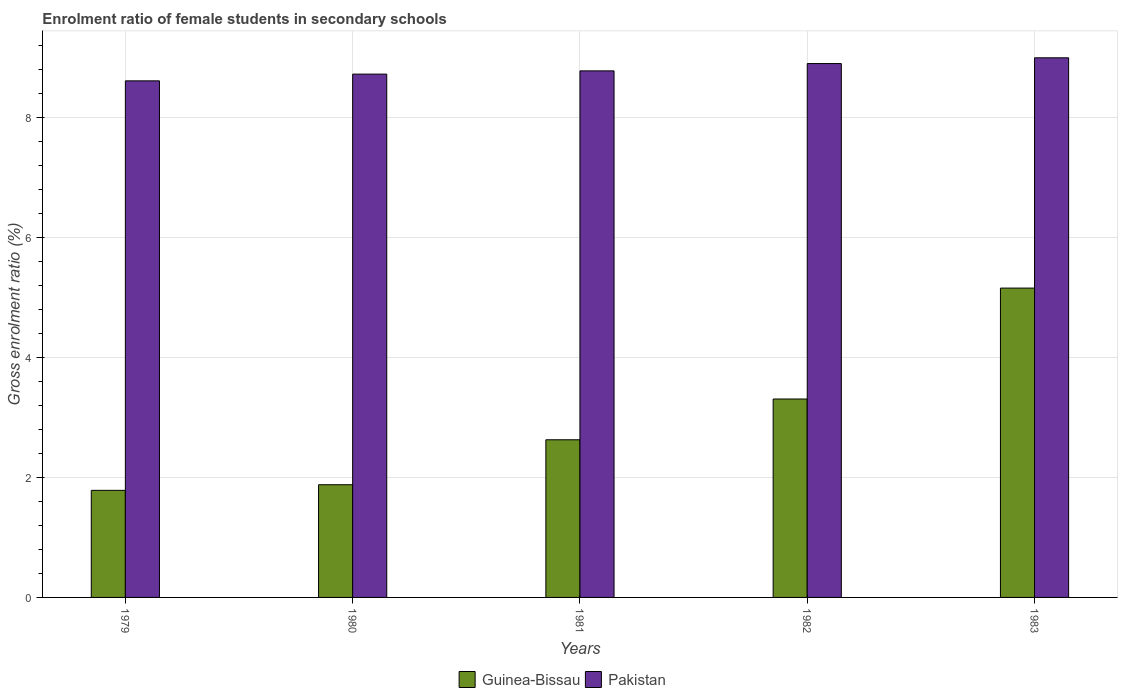How many groups of bars are there?
Offer a terse response. 5. Are the number of bars per tick equal to the number of legend labels?
Your answer should be very brief. Yes. How many bars are there on the 5th tick from the right?
Give a very brief answer. 2. What is the label of the 5th group of bars from the left?
Provide a short and direct response. 1983. What is the enrolment ratio of female students in secondary schools in Guinea-Bissau in 1980?
Provide a short and direct response. 1.88. Across all years, what is the maximum enrolment ratio of female students in secondary schools in Guinea-Bissau?
Your answer should be very brief. 5.16. Across all years, what is the minimum enrolment ratio of female students in secondary schools in Pakistan?
Your answer should be very brief. 8.61. In which year was the enrolment ratio of female students in secondary schools in Pakistan minimum?
Offer a terse response. 1979. What is the total enrolment ratio of female students in secondary schools in Guinea-Bissau in the graph?
Give a very brief answer. 14.75. What is the difference between the enrolment ratio of female students in secondary schools in Pakistan in 1980 and that in 1982?
Offer a very short reply. -0.18. What is the difference between the enrolment ratio of female students in secondary schools in Pakistan in 1983 and the enrolment ratio of female students in secondary schools in Guinea-Bissau in 1979?
Give a very brief answer. 7.21. What is the average enrolment ratio of female students in secondary schools in Guinea-Bissau per year?
Provide a short and direct response. 2.95. In the year 1981, what is the difference between the enrolment ratio of female students in secondary schools in Guinea-Bissau and enrolment ratio of female students in secondary schools in Pakistan?
Your response must be concise. -6.15. In how many years, is the enrolment ratio of female students in secondary schools in Guinea-Bissau greater than 4.4 %?
Keep it short and to the point. 1. What is the ratio of the enrolment ratio of female students in secondary schools in Pakistan in 1980 to that in 1983?
Offer a very short reply. 0.97. Is the enrolment ratio of female students in secondary schools in Pakistan in 1981 less than that in 1983?
Provide a succinct answer. Yes. Is the difference between the enrolment ratio of female students in secondary schools in Guinea-Bissau in 1980 and 1983 greater than the difference between the enrolment ratio of female students in secondary schools in Pakistan in 1980 and 1983?
Keep it short and to the point. No. What is the difference between the highest and the second highest enrolment ratio of female students in secondary schools in Guinea-Bissau?
Keep it short and to the point. 1.85. What is the difference between the highest and the lowest enrolment ratio of female students in secondary schools in Guinea-Bissau?
Ensure brevity in your answer.  3.37. In how many years, is the enrolment ratio of female students in secondary schools in Pakistan greater than the average enrolment ratio of female students in secondary schools in Pakistan taken over all years?
Provide a short and direct response. 2. Is the sum of the enrolment ratio of female students in secondary schools in Guinea-Bissau in 1980 and 1982 greater than the maximum enrolment ratio of female students in secondary schools in Pakistan across all years?
Provide a succinct answer. No. What does the 2nd bar from the left in 1980 represents?
Provide a succinct answer. Pakistan. What does the 1st bar from the right in 1980 represents?
Your answer should be very brief. Pakistan. How many bars are there?
Your answer should be compact. 10. Are all the bars in the graph horizontal?
Make the answer very short. No. How many years are there in the graph?
Provide a succinct answer. 5. Are the values on the major ticks of Y-axis written in scientific E-notation?
Keep it short and to the point. No. Does the graph contain grids?
Your answer should be compact. Yes. How many legend labels are there?
Offer a very short reply. 2. What is the title of the graph?
Keep it short and to the point. Enrolment ratio of female students in secondary schools. Does "Kyrgyz Republic" appear as one of the legend labels in the graph?
Ensure brevity in your answer.  No. What is the label or title of the Y-axis?
Your answer should be very brief. Gross enrolment ratio (%). What is the Gross enrolment ratio (%) in Guinea-Bissau in 1979?
Provide a succinct answer. 1.78. What is the Gross enrolment ratio (%) in Pakistan in 1979?
Your answer should be compact. 8.61. What is the Gross enrolment ratio (%) of Guinea-Bissau in 1980?
Your answer should be compact. 1.88. What is the Gross enrolment ratio (%) of Pakistan in 1980?
Keep it short and to the point. 8.72. What is the Gross enrolment ratio (%) in Guinea-Bissau in 1981?
Keep it short and to the point. 2.63. What is the Gross enrolment ratio (%) of Pakistan in 1981?
Provide a short and direct response. 8.78. What is the Gross enrolment ratio (%) in Guinea-Bissau in 1982?
Offer a very short reply. 3.31. What is the Gross enrolment ratio (%) in Pakistan in 1982?
Give a very brief answer. 8.9. What is the Gross enrolment ratio (%) of Guinea-Bissau in 1983?
Provide a succinct answer. 5.16. What is the Gross enrolment ratio (%) of Pakistan in 1983?
Provide a succinct answer. 8.99. Across all years, what is the maximum Gross enrolment ratio (%) of Guinea-Bissau?
Your answer should be very brief. 5.16. Across all years, what is the maximum Gross enrolment ratio (%) of Pakistan?
Give a very brief answer. 8.99. Across all years, what is the minimum Gross enrolment ratio (%) in Guinea-Bissau?
Provide a short and direct response. 1.78. Across all years, what is the minimum Gross enrolment ratio (%) of Pakistan?
Ensure brevity in your answer.  8.61. What is the total Gross enrolment ratio (%) of Guinea-Bissau in the graph?
Provide a succinct answer. 14.75. What is the total Gross enrolment ratio (%) of Pakistan in the graph?
Your answer should be very brief. 44. What is the difference between the Gross enrolment ratio (%) of Guinea-Bissau in 1979 and that in 1980?
Provide a succinct answer. -0.09. What is the difference between the Gross enrolment ratio (%) of Pakistan in 1979 and that in 1980?
Ensure brevity in your answer.  -0.11. What is the difference between the Gross enrolment ratio (%) of Guinea-Bissau in 1979 and that in 1981?
Offer a very short reply. -0.84. What is the difference between the Gross enrolment ratio (%) of Pakistan in 1979 and that in 1981?
Offer a terse response. -0.17. What is the difference between the Gross enrolment ratio (%) of Guinea-Bissau in 1979 and that in 1982?
Your response must be concise. -1.52. What is the difference between the Gross enrolment ratio (%) in Pakistan in 1979 and that in 1982?
Your answer should be very brief. -0.29. What is the difference between the Gross enrolment ratio (%) in Guinea-Bissau in 1979 and that in 1983?
Give a very brief answer. -3.37. What is the difference between the Gross enrolment ratio (%) in Pakistan in 1979 and that in 1983?
Offer a terse response. -0.38. What is the difference between the Gross enrolment ratio (%) of Guinea-Bissau in 1980 and that in 1981?
Your answer should be very brief. -0.75. What is the difference between the Gross enrolment ratio (%) in Pakistan in 1980 and that in 1981?
Make the answer very short. -0.05. What is the difference between the Gross enrolment ratio (%) of Guinea-Bissau in 1980 and that in 1982?
Make the answer very short. -1.43. What is the difference between the Gross enrolment ratio (%) of Pakistan in 1980 and that in 1982?
Provide a succinct answer. -0.18. What is the difference between the Gross enrolment ratio (%) in Guinea-Bissau in 1980 and that in 1983?
Keep it short and to the point. -3.28. What is the difference between the Gross enrolment ratio (%) of Pakistan in 1980 and that in 1983?
Provide a short and direct response. -0.27. What is the difference between the Gross enrolment ratio (%) of Guinea-Bissau in 1981 and that in 1982?
Provide a short and direct response. -0.68. What is the difference between the Gross enrolment ratio (%) of Pakistan in 1981 and that in 1982?
Provide a short and direct response. -0.12. What is the difference between the Gross enrolment ratio (%) in Guinea-Bissau in 1981 and that in 1983?
Give a very brief answer. -2.53. What is the difference between the Gross enrolment ratio (%) in Pakistan in 1981 and that in 1983?
Make the answer very short. -0.22. What is the difference between the Gross enrolment ratio (%) of Guinea-Bissau in 1982 and that in 1983?
Give a very brief answer. -1.85. What is the difference between the Gross enrolment ratio (%) in Pakistan in 1982 and that in 1983?
Make the answer very short. -0.1. What is the difference between the Gross enrolment ratio (%) in Guinea-Bissau in 1979 and the Gross enrolment ratio (%) in Pakistan in 1980?
Your answer should be compact. -6.94. What is the difference between the Gross enrolment ratio (%) of Guinea-Bissau in 1979 and the Gross enrolment ratio (%) of Pakistan in 1981?
Provide a succinct answer. -6.99. What is the difference between the Gross enrolment ratio (%) of Guinea-Bissau in 1979 and the Gross enrolment ratio (%) of Pakistan in 1982?
Provide a succinct answer. -7.11. What is the difference between the Gross enrolment ratio (%) in Guinea-Bissau in 1979 and the Gross enrolment ratio (%) in Pakistan in 1983?
Your response must be concise. -7.21. What is the difference between the Gross enrolment ratio (%) of Guinea-Bissau in 1980 and the Gross enrolment ratio (%) of Pakistan in 1981?
Keep it short and to the point. -6.9. What is the difference between the Gross enrolment ratio (%) of Guinea-Bissau in 1980 and the Gross enrolment ratio (%) of Pakistan in 1982?
Ensure brevity in your answer.  -7.02. What is the difference between the Gross enrolment ratio (%) of Guinea-Bissau in 1980 and the Gross enrolment ratio (%) of Pakistan in 1983?
Your answer should be very brief. -7.12. What is the difference between the Gross enrolment ratio (%) in Guinea-Bissau in 1981 and the Gross enrolment ratio (%) in Pakistan in 1982?
Offer a terse response. -6.27. What is the difference between the Gross enrolment ratio (%) of Guinea-Bissau in 1981 and the Gross enrolment ratio (%) of Pakistan in 1983?
Your answer should be compact. -6.37. What is the difference between the Gross enrolment ratio (%) of Guinea-Bissau in 1982 and the Gross enrolment ratio (%) of Pakistan in 1983?
Provide a short and direct response. -5.69. What is the average Gross enrolment ratio (%) of Guinea-Bissau per year?
Provide a short and direct response. 2.95. What is the average Gross enrolment ratio (%) in Pakistan per year?
Provide a short and direct response. 8.8. In the year 1979, what is the difference between the Gross enrolment ratio (%) of Guinea-Bissau and Gross enrolment ratio (%) of Pakistan?
Provide a succinct answer. -6.82. In the year 1980, what is the difference between the Gross enrolment ratio (%) in Guinea-Bissau and Gross enrolment ratio (%) in Pakistan?
Your answer should be compact. -6.84. In the year 1981, what is the difference between the Gross enrolment ratio (%) in Guinea-Bissau and Gross enrolment ratio (%) in Pakistan?
Your answer should be compact. -6.15. In the year 1982, what is the difference between the Gross enrolment ratio (%) of Guinea-Bissau and Gross enrolment ratio (%) of Pakistan?
Make the answer very short. -5.59. In the year 1983, what is the difference between the Gross enrolment ratio (%) in Guinea-Bissau and Gross enrolment ratio (%) in Pakistan?
Your response must be concise. -3.84. What is the ratio of the Gross enrolment ratio (%) in Guinea-Bissau in 1979 to that in 1980?
Ensure brevity in your answer.  0.95. What is the ratio of the Gross enrolment ratio (%) of Pakistan in 1979 to that in 1980?
Your response must be concise. 0.99. What is the ratio of the Gross enrolment ratio (%) of Guinea-Bissau in 1979 to that in 1981?
Offer a terse response. 0.68. What is the ratio of the Gross enrolment ratio (%) in Pakistan in 1979 to that in 1981?
Keep it short and to the point. 0.98. What is the ratio of the Gross enrolment ratio (%) in Guinea-Bissau in 1979 to that in 1982?
Your answer should be compact. 0.54. What is the ratio of the Gross enrolment ratio (%) in Pakistan in 1979 to that in 1982?
Make the answer very short. 0.97. What is the ratio of the Gross enrolment ratio (%) in Guinea-Bissau in 1979 to that in 1983?
Provide a short and direct response. 0.35. What is the ratio of the Gross enrolment ratio (%) of Pakistan in 1979 to that in 1983?
Offer a terse response. 0.96. What is the ratio of the Gross enrolment ratio (%) of Guinea-Bissau in 1980 to that in 1981?
Your answer should be compact. 0.71. What is the ratio of the Gross enrolment ratio (%) in Guinea-Bissau in 1980 to that in 1982?
Keep it short and to the point. 0.57. What is the ratio of the Gross enrolment ratio (%) of Pakistan in 1980 to that in 1982?
Make the answer very short. 0.98. What is the ratio of the Gross enrolment ratio (%) in Guinea-Bissau in 1980 to that in 1983?
Provide a short and direct response. 0.36. What is the ratio of the Gross enrolment ratio (%) of Pakistan in 1980 to that in 1983?
Your answer should be very brief. 0.97. What is the ratio of the Gross enrolment ratio (%) in Guinea-Bissau in 1981 to that in 1982?
Make the answer very short. 0.79. What is the ratio of the Gross enrolment ratio (%) in Pakistan in 1981 to that in 1982?
Provide a succinct answer. 0.99. What is the ratio of the Gross enrolment ratio (%) of Guinea-Bissau in 1981 to that in 1983?
Your answer should be compact. 0.51. What is the ratio of the Gross enrolment ratio (%) in Pakistan in 1981 to that in 1983?
Your response must be concise. 0.98. What is the ratio of the Gross enrolment ratio (%) of Guinea-Bissau in 1982 to that in 1983?
Offer a very short reply. 0.64. What is the ratio of the Gross enrolment ratio (%) in Pakistan in 1982 to that in 1983?
Your response must be concise. 0.99. What is the difference between the highest and the second highest Gross enrolment ratio (%) in Guinea-Bissau?
Keep it short and to the point. 1.85. What is the difference between the highest and the second highest Gross enrolment ratio (%) in Pakistan?
Your response must be concise. 0.1. What is the difference between the highest and the lowest Gross enrolment ratio (%) of Guinea-Bissau?
Offer a very short reply. 3.37. What is the difference between the highest and the lowest Gross enrolment ratio (%) of Pakistan?
Give a very brief answer. 0.38. 